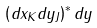Convert formula to latex. <formula><loc_0><loc_0><loc_500><loc_500>\left ( d x _ { K } d y _ { J } \right ) ^ { * } d y</formula> 